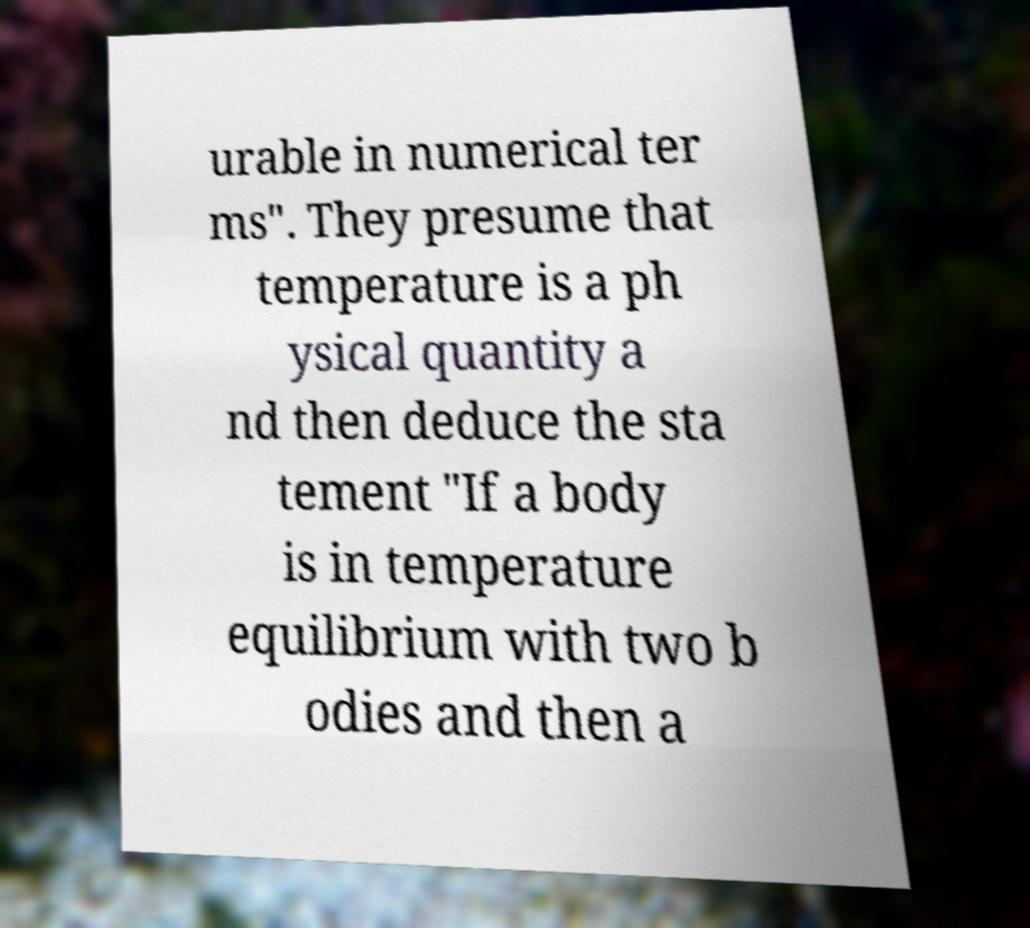Can you accurately transcribe the text from the provided image for me? urable in numerical ter ms". They presume that temperature is a ph ysical quantity a nd then deduce the sta tement "If a body is in temperature equilibrium with two b odies and then a 